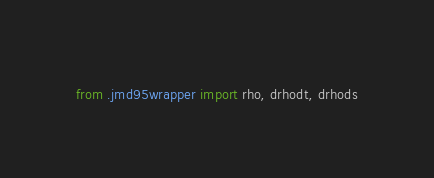<code> <loc_0><loc_0><loc_500><loc_500><_Python_>from .jmd95wrapper import rho, drhodt, drhods</code> 